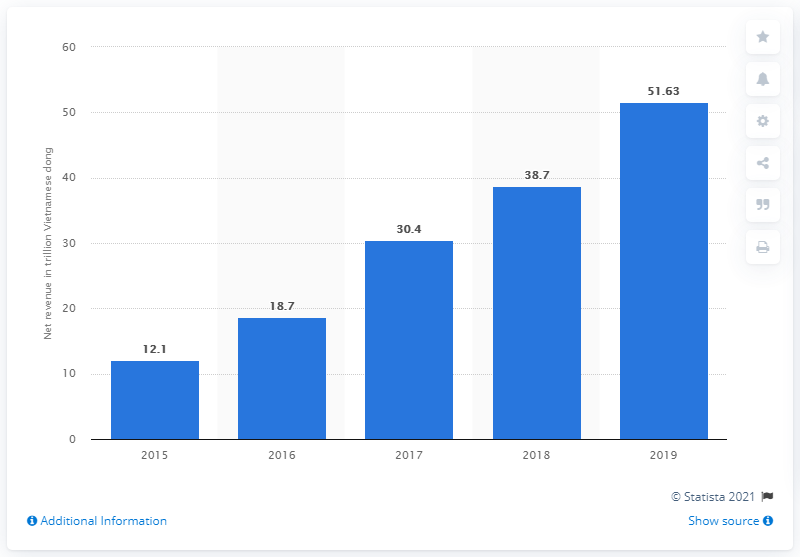Outline some significant characteristics in this image. In 2019, Vinhomes' net revenue was approximately 51.63. 